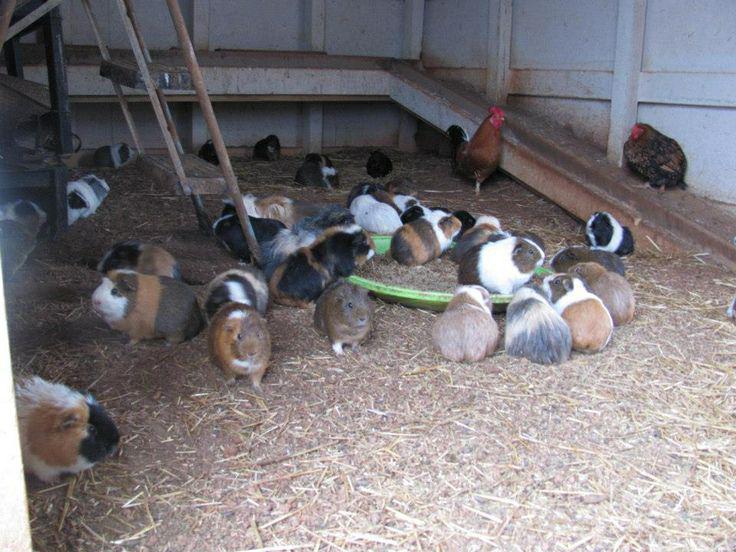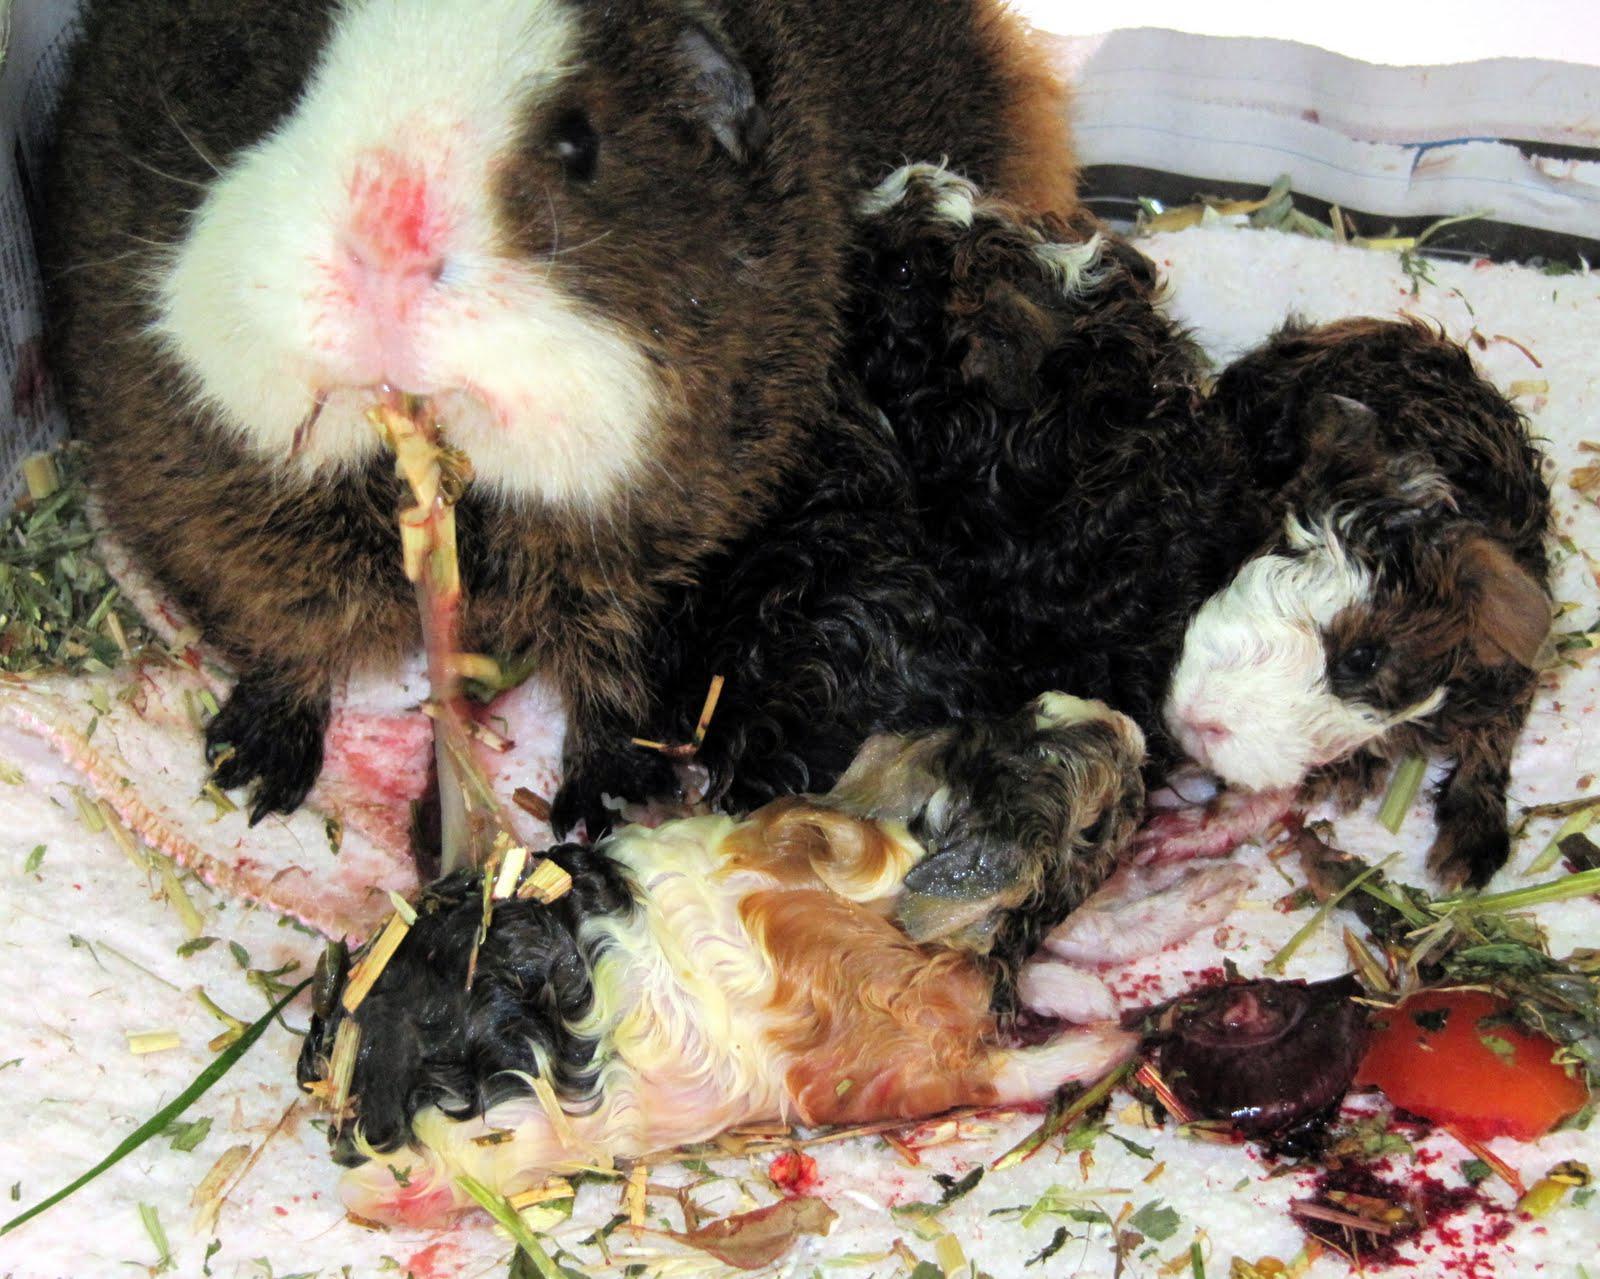The first image is the image on the left, the second image is the image on the right. Given the left and right images, does the statement "The guinea pigs are eating in both images and are eating fresh green vegetation in one of the images." hold true? Answer yes or no. Yes. The first image is the image on the left, the second image is the image on the right. Assess this claim about the two images: "One image includes no more than five hamsters.". Correct or not? Answer yes or no. Yes. 